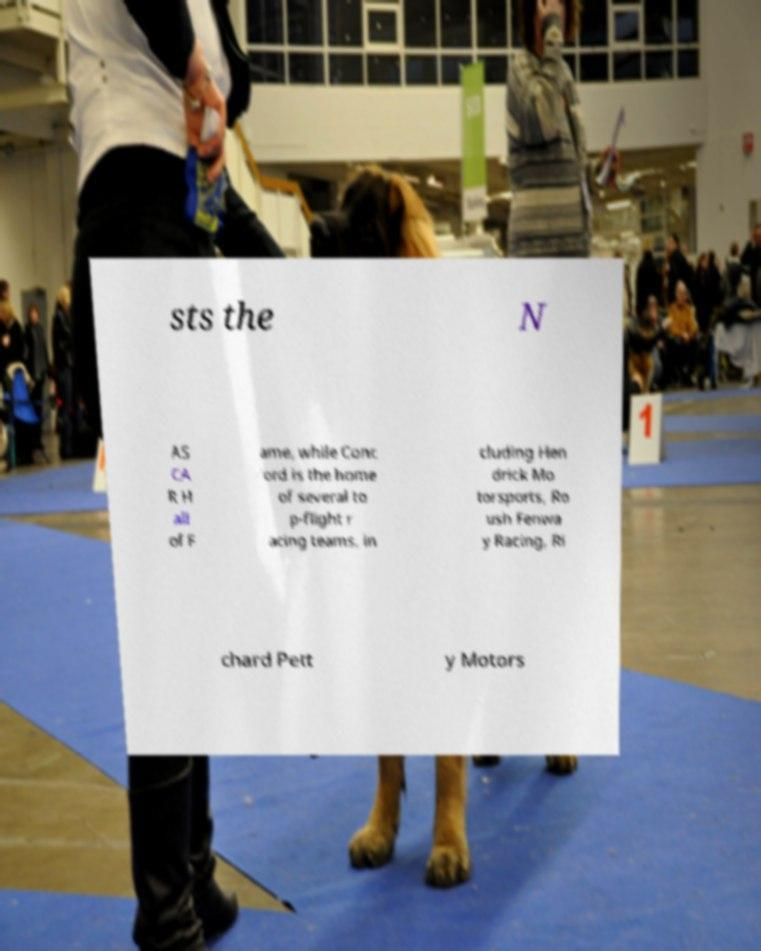For documentation purposes, I need the text within this image transcribed. Could you provide that? sts the N AS CA R H all of F ame, while Conc ord is the home of several to p-flight r acing teams, in cluding Hen drick Mo torsports, Ro ush Fenwa y Racing, Ri chard Pett y Motors 